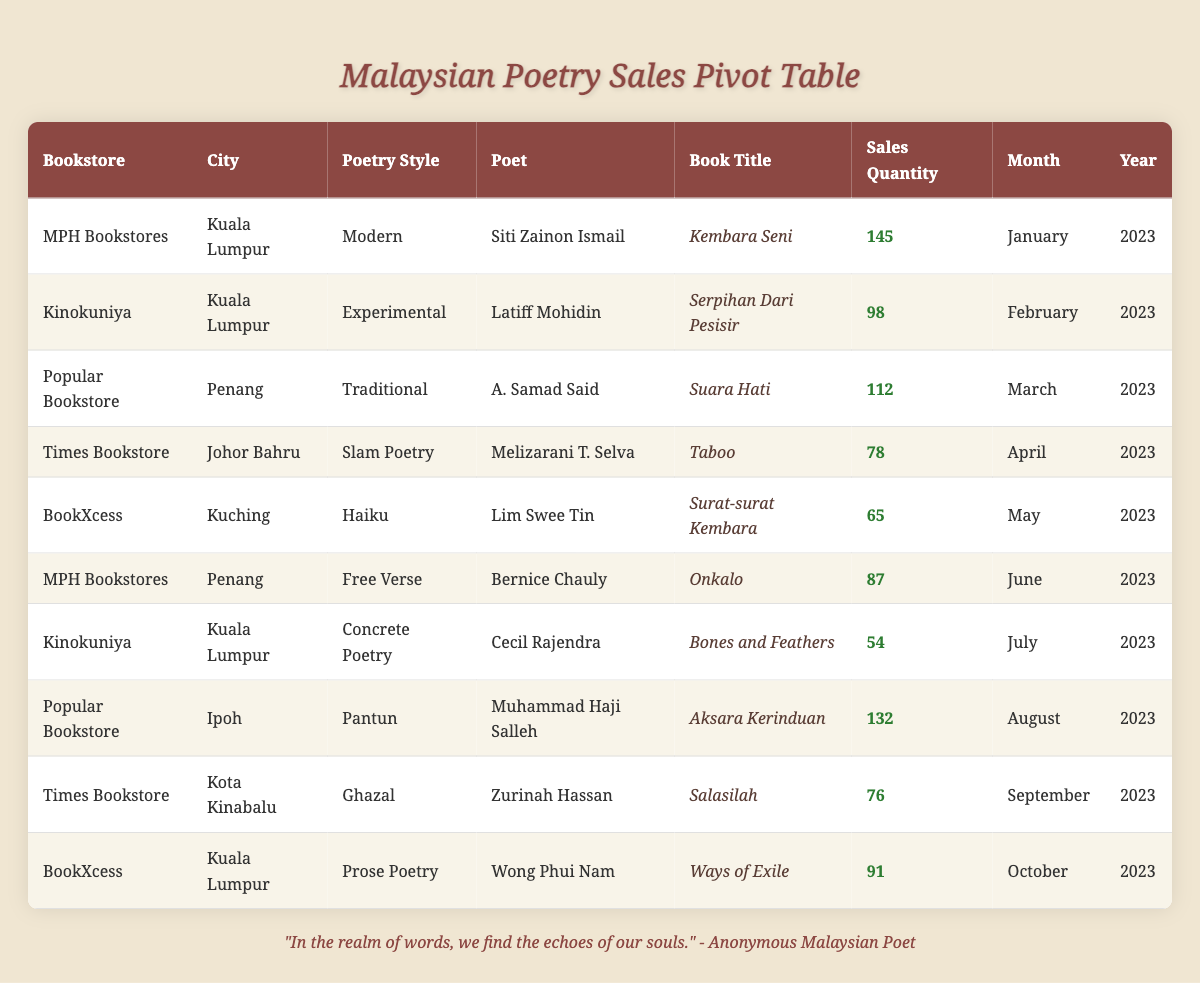What is the highest-selling poetry style in the table? By scanning through the sales quantities for each poetry style, we find that "Modern" poetry has the highest sales quantity of 145, as listed under MPH Bookstores in Kuala Lumpur for January 2023.
Answer: Modern Which bookstore sold the most copies of poetry books? The bookstore with the highest sales quantity is MPH Bookstores, with a total of 145 copies sold for the "Modern" poetry book "Kembara Seni."
Answer: MPH Bookstores How many copies of "Aksara Kerinduan" were sold? The table indicates that "Aksara Kerinduan," a Pantun book by Muhammad Haji Salleh sold 132 copies at Popular Bookstore in Ipoh during August 2023.
Answer: 132 What is the total sales quantity for all books in the table? Adding all sales quantities: 145 + 98 + 112 + 78 + 65 + 87 + 54 + 132 + 76 + 91 gives us a total of 1,036 copies sold across the different poetry styles.
Answer: 1036 Is there a book that has more than 100 copies sold in April 2023? In April 2023, "Taboo," a Slam Poetry book by Melizarani T. Selva only sold 78 copies, which is less than 100. Therefore, there are no books sold in April that exceeded 100 copies.
Answer: No What is the average sales quantity of poetry books sold across all the months shown? To find the average, we sum the sales quantities which total 1,036 and divide by the number of entries (10): 1,036 / 10 = 103.6. Therefore, the average sales quantity is approximately 104.
Answer: 104 Which poet sold the least number of books and what was the quantity? By comparing the sales quantities, we see that Cecil Rajendra sold the least, with 54 copies of the "Concrete Poetry" book "Bones and Feathers" in July 2023.
Answer: Cecil Rajendra, 54 In which city were copies of "Ways of Exile" sold? "Ways of Exile," authored by Wong Phui Nam, was sold at BookXcess located in Kuala Lumpur as indicated in the table.
Answer: Kuala Lumpur Were there any Slam Poetry books that sold above 80 copies? The only Slam Poetry book listed is "Taboo," which sold 78 copies, thus it did not exceed the 80-copy mark.
Answer: No 